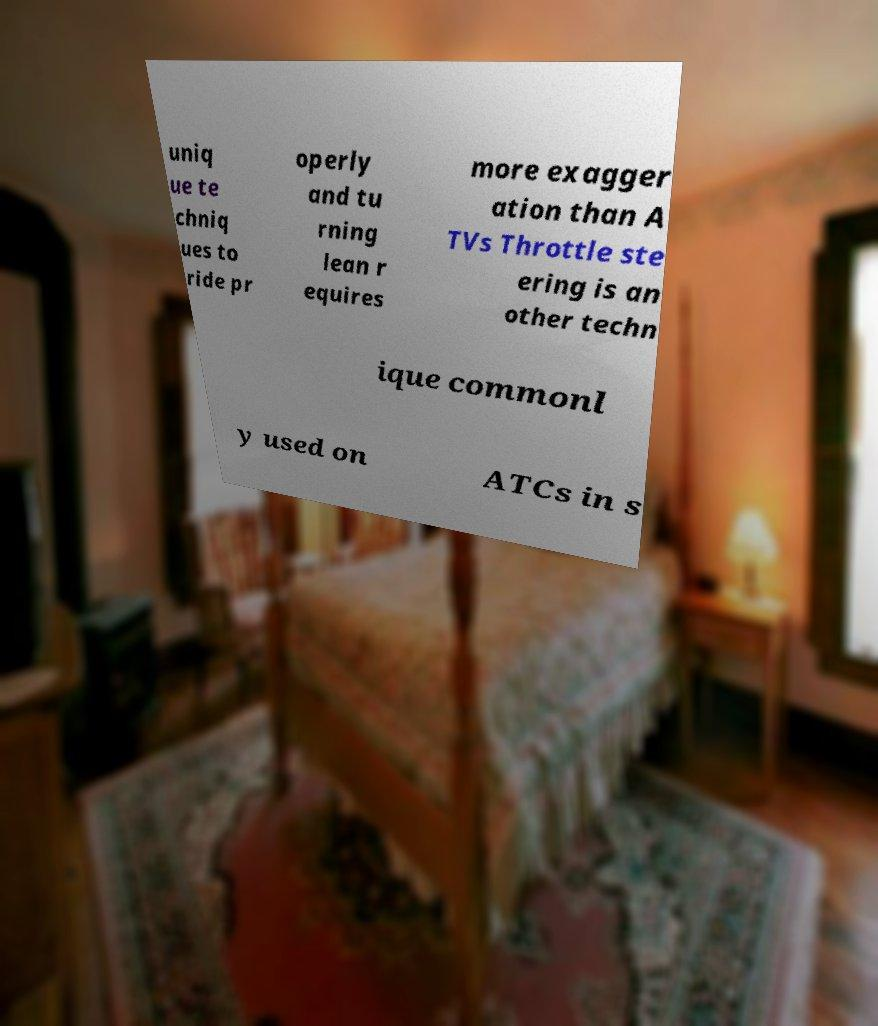Could you extract and type out the text from this image? uniq ue te chniq ues to ride pr operly and tu rning lean r equires more exagger ation than A TVs Throttle ste ering is an other techn ique commonl y used on ATCs in s 